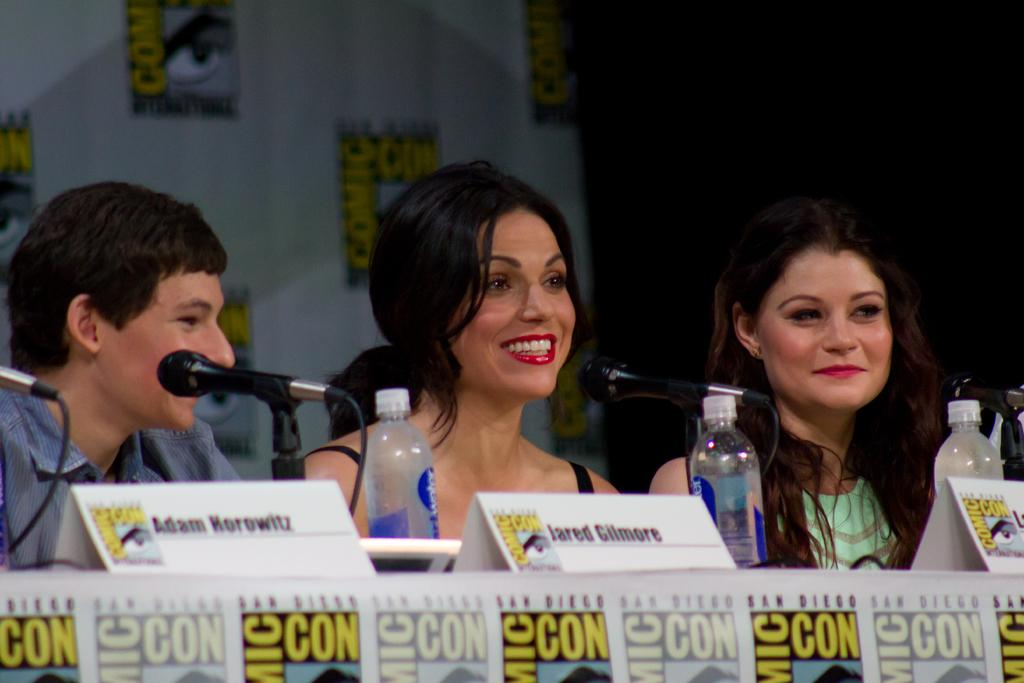How many people are in the image? There are three individuals in the image: two women and one man. What is the facial expression of the people in the image? All three individuals are smiling in the image. What object can be seen in the image that is typically used for amplifying sound? There is a microphone in the image. What items are present on the table in the image? There are water bottles on the table in the image. What type of truck can be seen in the image? There is no truck present in the image. Is there a carpenter working on a project in the image? There is no carpenter or any indication of a carpentry project in the image. 